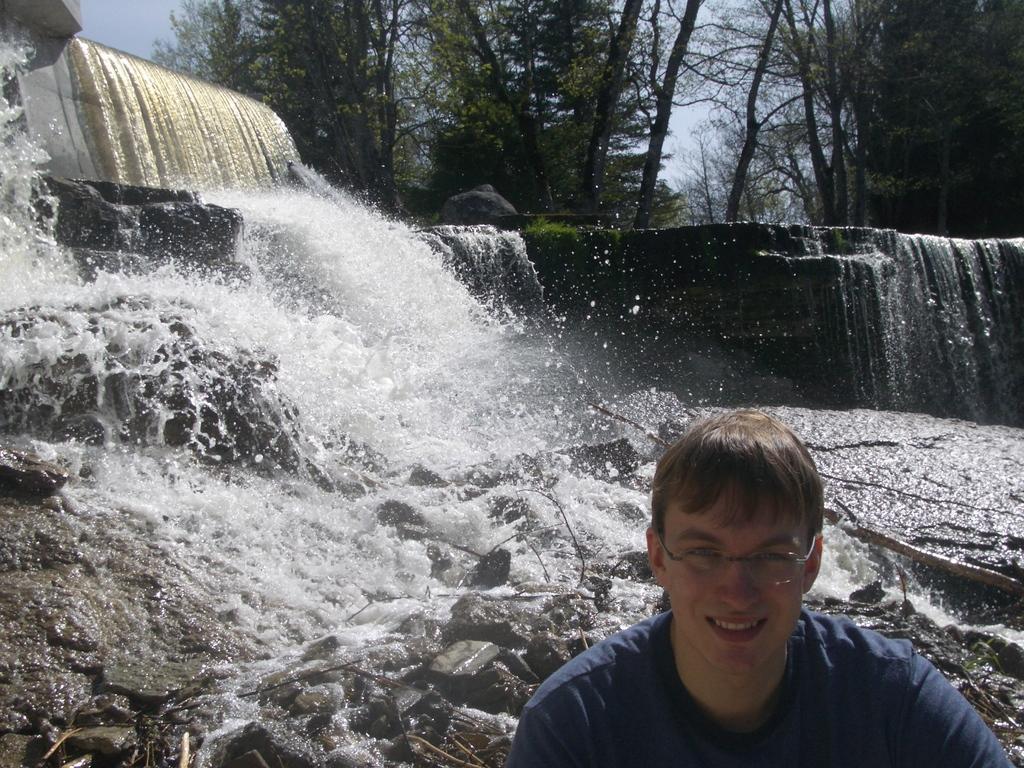In one or two sentences, can you explain what this image depicts? On the right corner there is a person wearing specs is smiling. In the back there is a waterfall on the rocks. In the background there are trees and sky. 